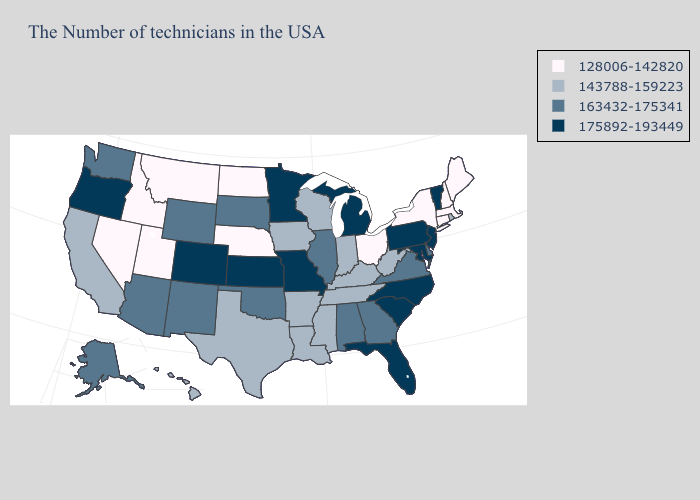What is the lowest value in the MidWest?
Concise answer only. 128006-142820. Which states hav the highest value in the South?
Answer briefly. Maryland, North Carolina, South Carolina, Florida. Name the states that have a value in the range 128006-142820?
Keep it brief. Maine, Massachusetts, New Hampshire, Connecticut, New York, Ohio, Nebraska, North Dakota, Utah, Montana, Idaho, Nevada. Does Texas have the lowest value in the South?
Give a very brief answer. Yes. Does Kentucky have the highest value in the USA?
Short answer required. No. Which states have the lowest value in the West?
Write a very short answer. Utah, Montana, Idaho, Nevada. What is the value of Washington?
Give a very brief answer. 163432-175341. Does New Jersey have the same value as Hawaii?
Answer briefly. No. Does the map have missing data?
Keep it brief. No. Among the states that border Kansas , does Colorado have the highest value?
Keep it brief. Yes. Is the legend a continuous bar?
Write a very short answer. No. Does the first symbol in the legend represent the smallest category?
Give a very brief answer. Yes. Does Wyoming have the lowest value in the West?
Give a very brief answer. No. What is the highest value in the USA?
Answer briefly. 175892-193449. Name the states that have a value in the range 128006-142820?
Quick response, please. Maine, Massachusetts, New Hampshire, Connecticut, New York, Ohio, Nebraska, North Dakota, Utah, Montana, Idaho, Nevada. 